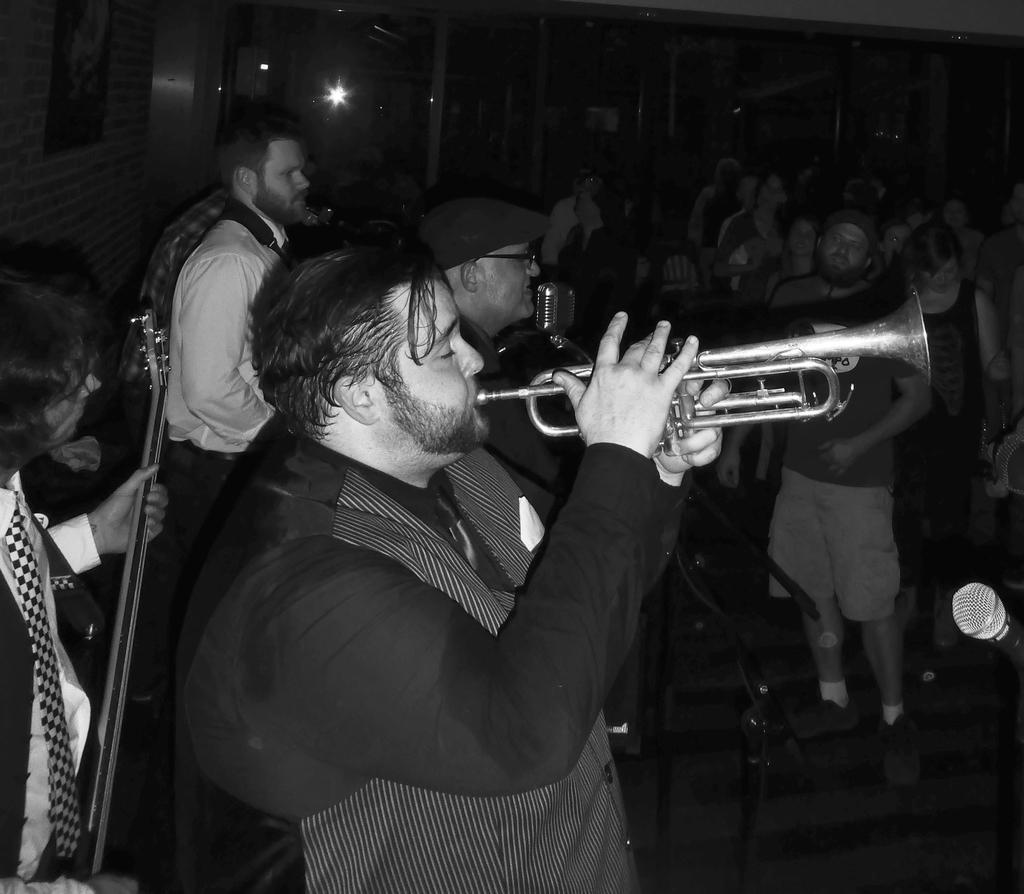How would you summarize this image in a sentence or two? In this image we can see a group of persons. In the foreground we can see the persons playing musical instruments. We can see a mic with a stand. In the top left, we can see a wall. On the right side, we can see a mic. The background of the image is dark. 